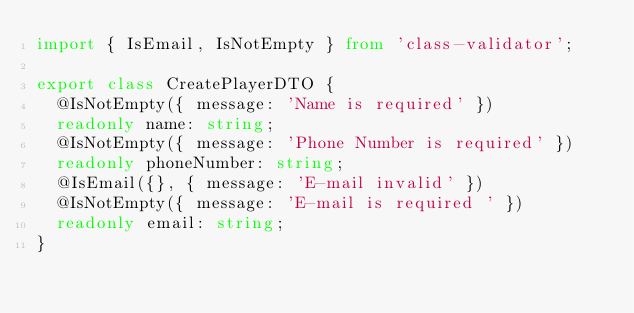<code> <loc_0><loc_0><loc_500><loc_500><_TypeScript_>import { IsEmail, IsNotEmpty } from 'class-validator';

export class CreatePlayerDTO {
  @IsNotEmpty({ message: 'Name is required' })
  readonly name: string;
  @IsNotEmpty({ message: 'Phone Number is required' })
  readonly phoneNumber: string;
  @IsEmail({}, { message: 'E-mail invalid' })
  @IsNotEmpty({ message: 'E-mail is required ' })
  readonly email: string;
}
</code> 